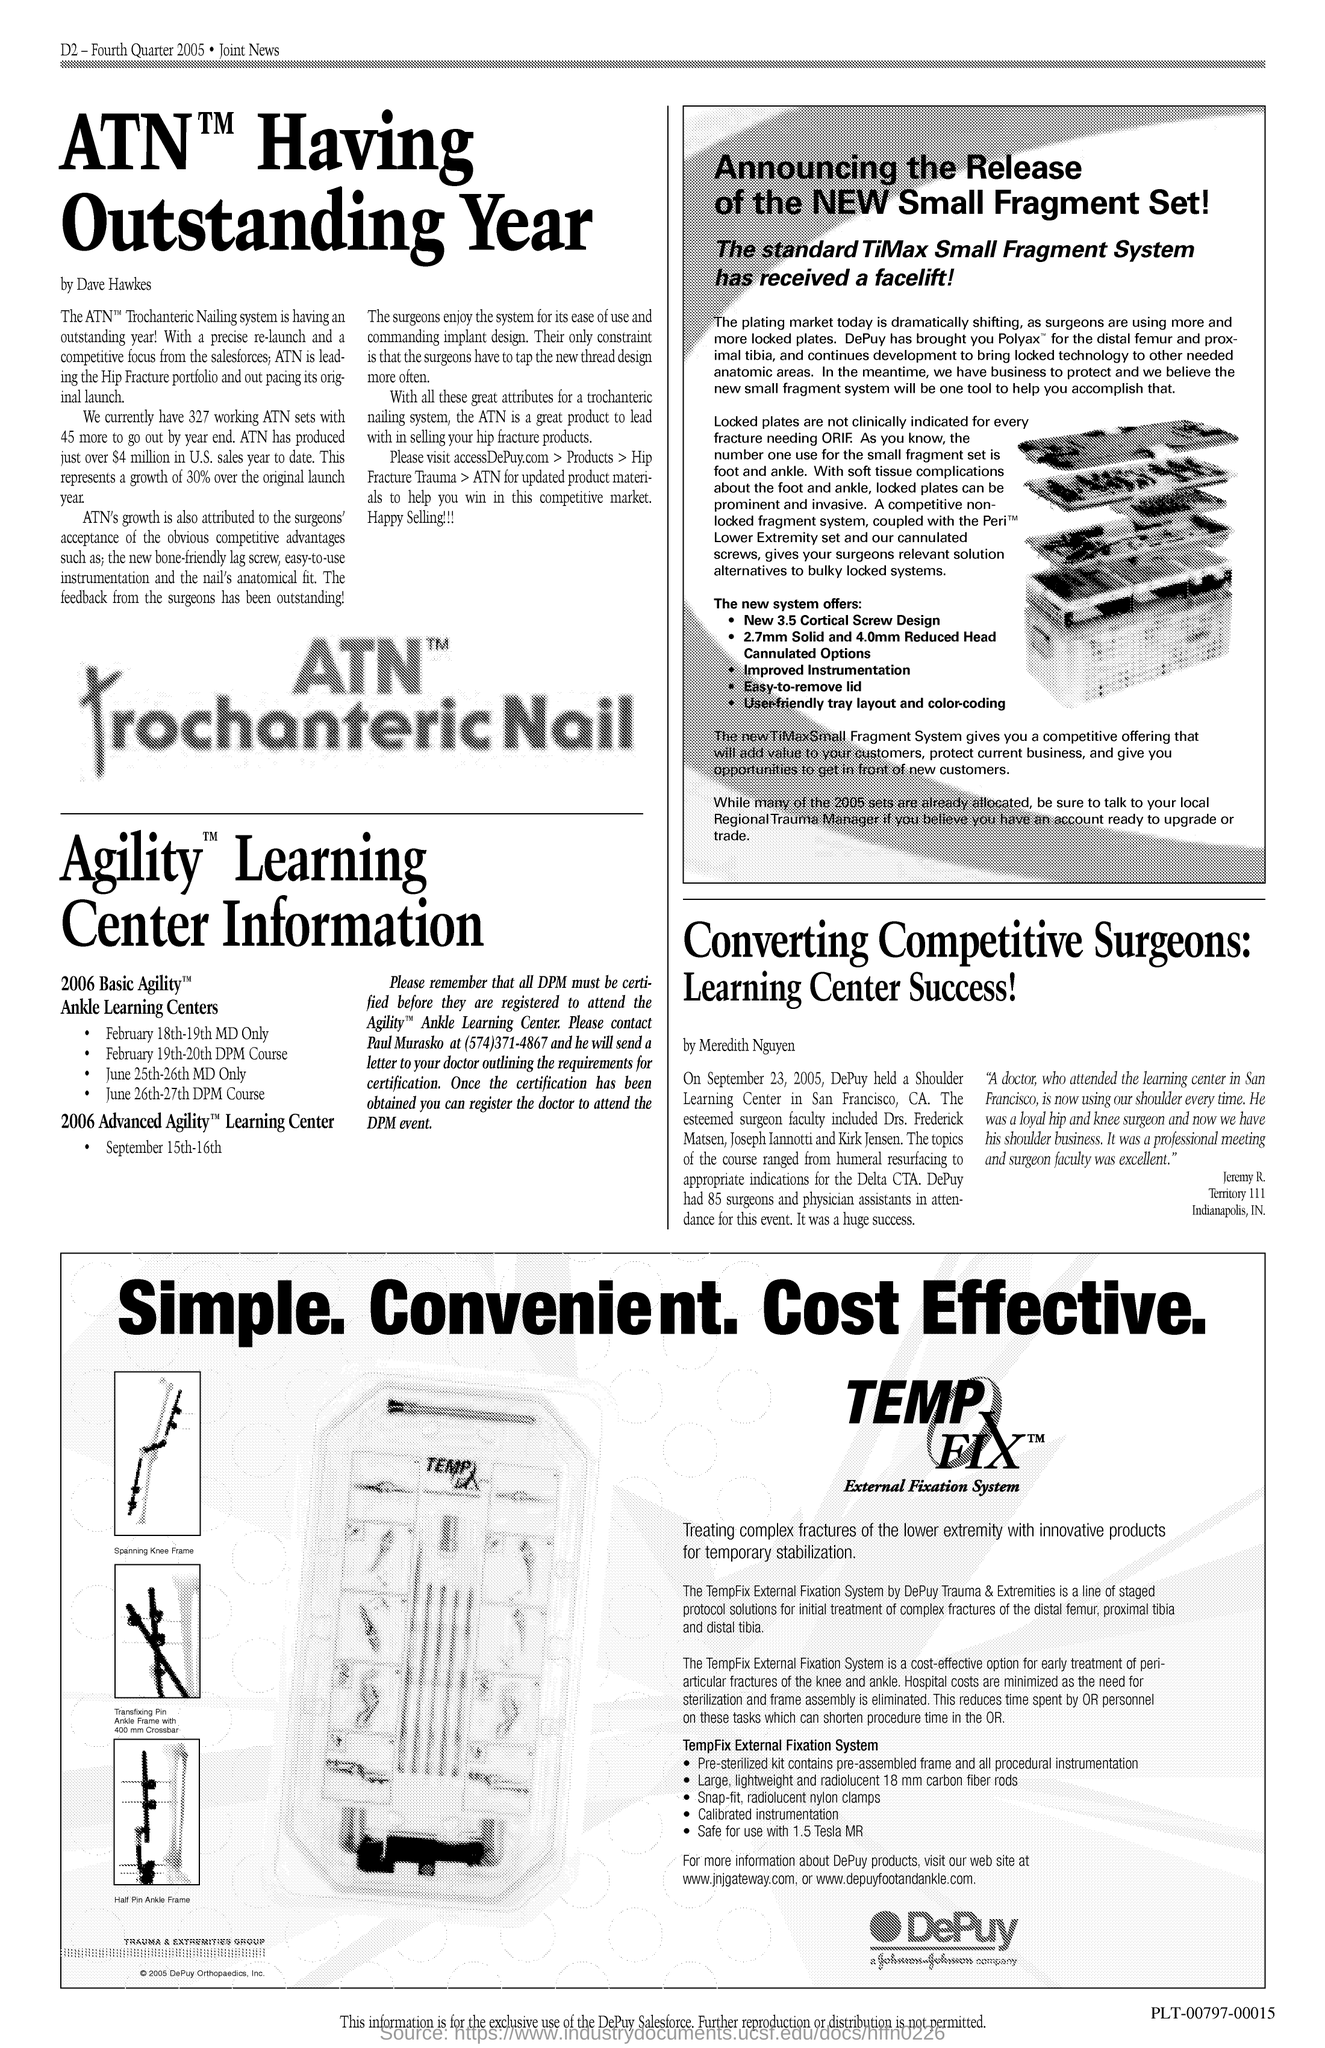Who is leading the hip fracture portfolio?
Ensure brevity in your answer.  ATN. How many atn sets are there currently?
Provide a short and direct response. 327. How many more ATN would go out by year end?
Ensure brevity in your answer.  45. What is the growth rate of atn over original launch year?
Ensure brevity in your answer.  30%. Why do the surgeons enjoy the system?
Give a very brief answer. For its ease of use and commanding implant design. Who is the author of the article on atn
Give a very brief answer. Dave Hawkes. 